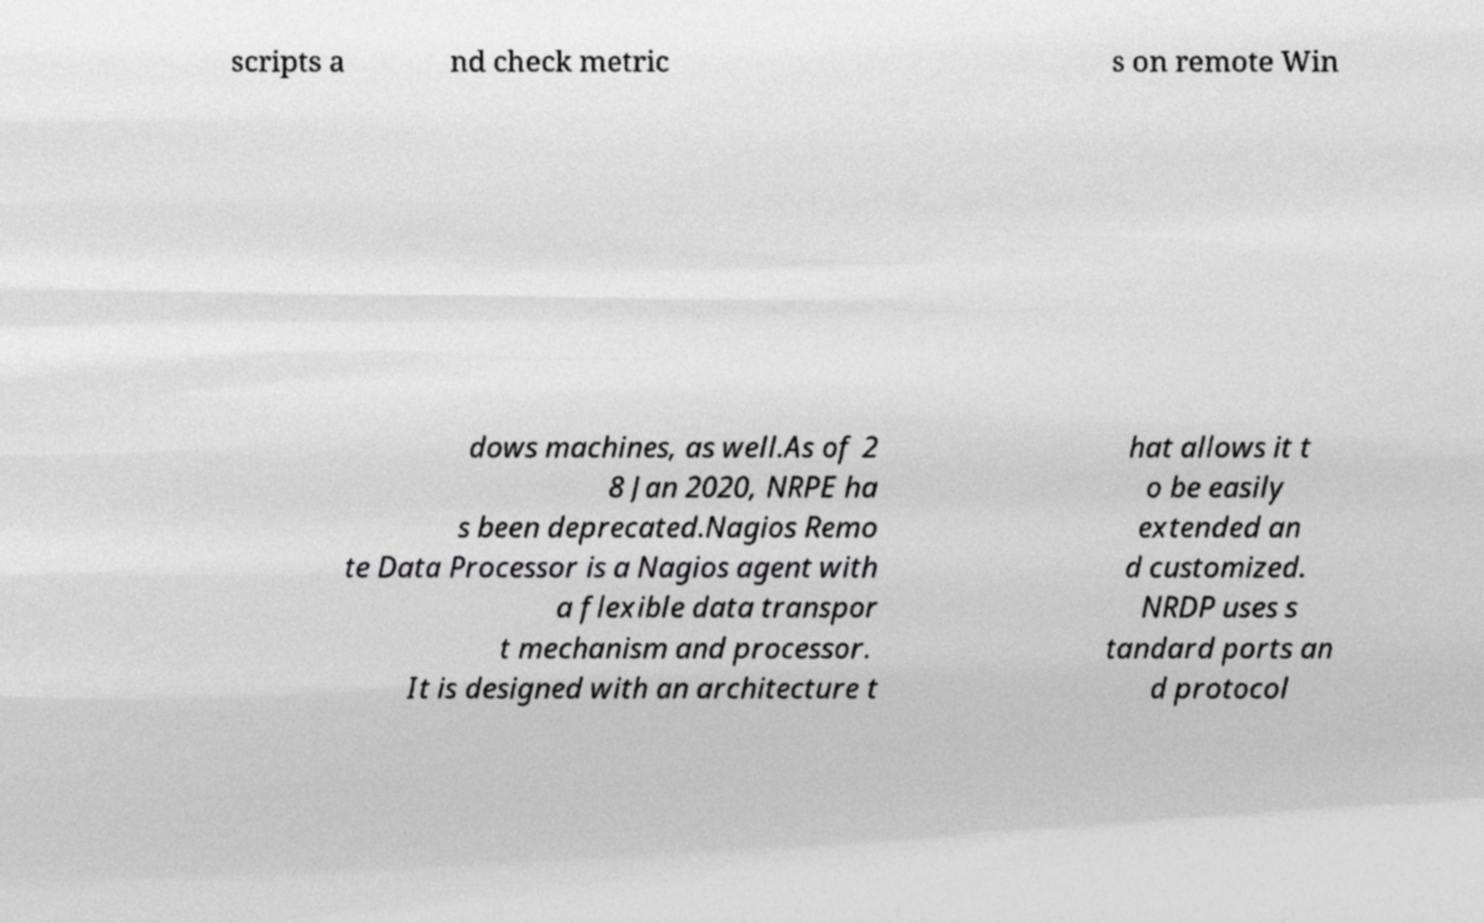There's text embedded in this image that I need extracted. Can you transcribe it verbatim? scripts a nd check metric s on remote Win dows machines, as well.As of 2 8 Jan 2020, NRPE ha s been deprecated.Nagios Remo te Data Processor is a Nagios agent with a flexible data transpor t mechanism and processor. It is designed with an architecture t hat allows it t o be easily extended an d customized. NRDP uses s tandard ports an d protocol 